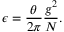<formula> <loc_0><loc_0><loc_500><loc_500>\epsilon = \frac { \theta } { 2 \pi } \frac { g ^ { 2 } } { N } .</formula> 